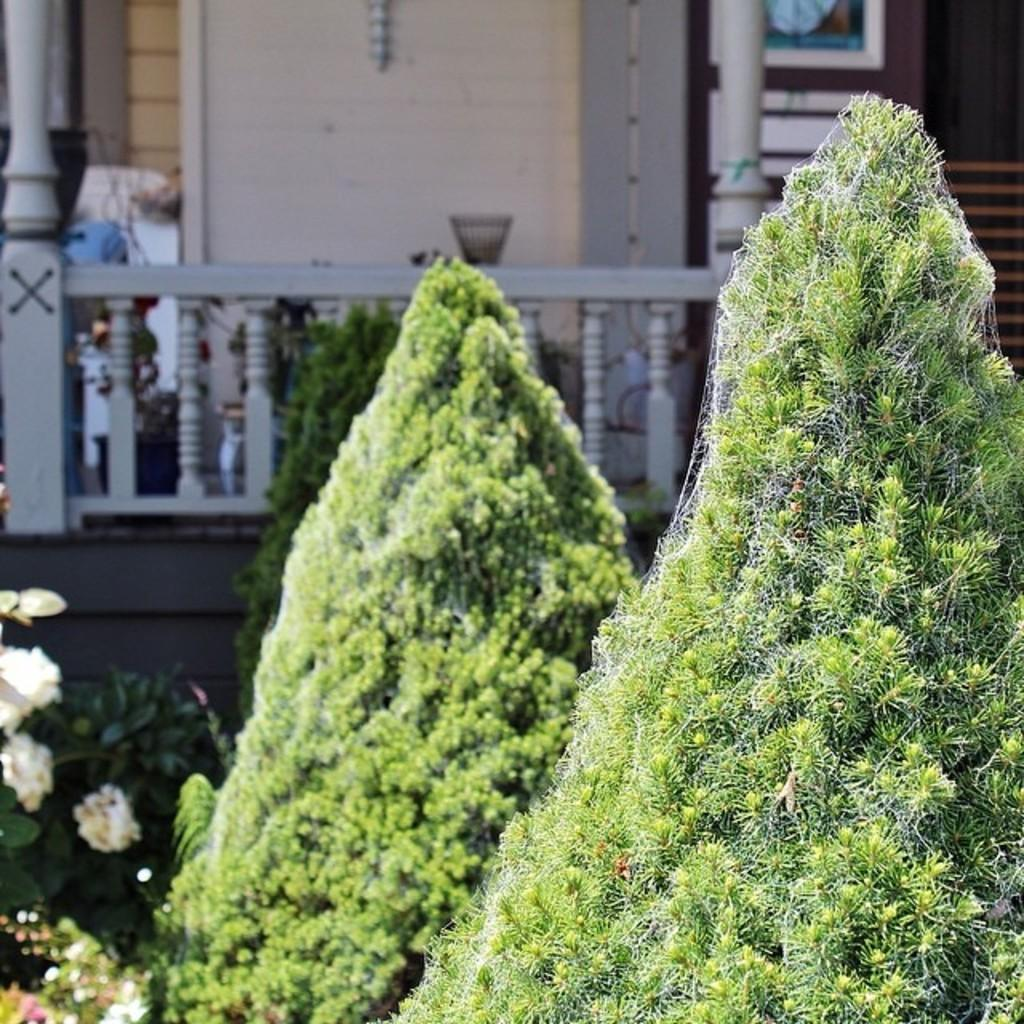What type of plants are in the image? There is a group of plants with flowers in the image. What can be seen in the background of the image? There is a building with poles and a wall in the background of the image. Where is the bowl placed in the image? The bowl is placed on a fence in the image. What causes the plants to feel shame in the image? There is no indication in the image that the plants are feeling shame, and plants do not have emotions like shame. 